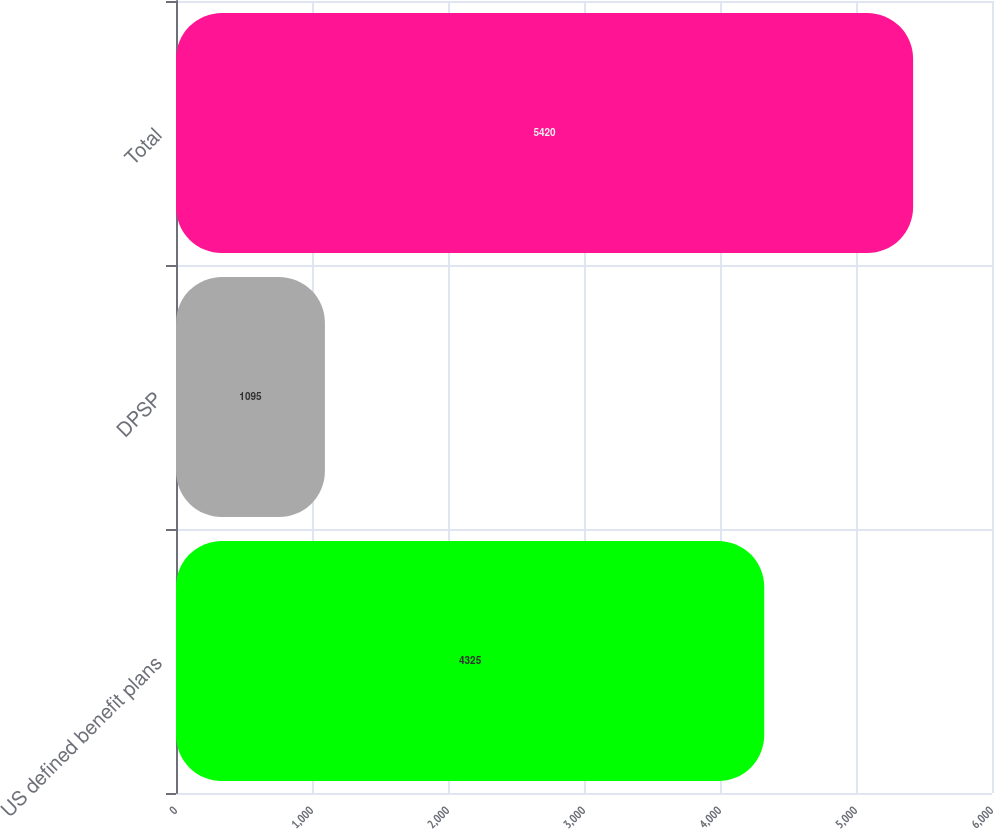<chart> <loc_0><loc_0><loc_500><loc_500><bar_chart><fcel>US defined benefit plans<fcel>DPSP<fcel>Total<nl><fcel>4325<fcel>1095<fcel>5420<nl></chart> 